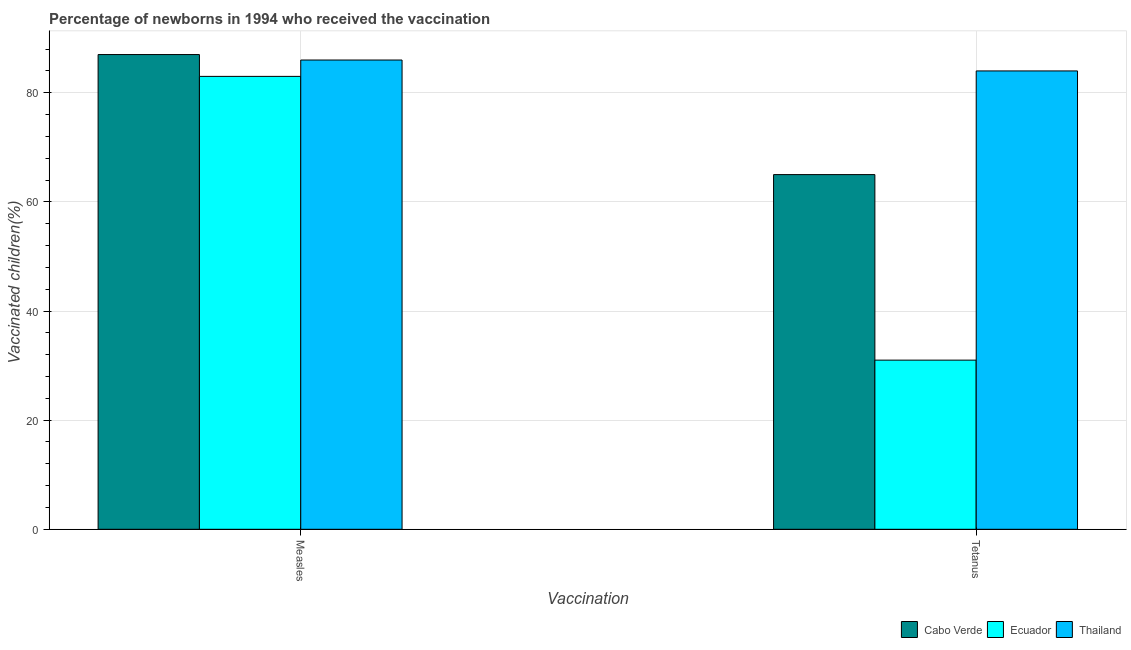How many groups of bars are there?
Your answer should be compact. 2. How many bars are there on the 2nd tick from the left?
Give a very brief answer. 3. What is the label of the 1st group of bars from the left?
Your response must be concise. Measles. What is the percentage of newborns who received vaccination for measles in Cabo Verde?
Provide a short and direct response. 87. Across all countries, what is the maximum percentage of newborns who received vaccination for measles?
Provide a short and direct response. 87. Across all countries, what is the minimum percentage of newborns who received vaccination for tetanus?
Keep it short and to the point. 31. In which country was the percentage of newborns who received vaccination for tetanus maximum?
Ensure brevity in your answer.  Thailand. In which country was the percentage of newborns who received vaccination for tetanus minimum?
Give a very brief answer. Ecuador. What is the total percentage of newborns who received vaccination for measles in the graph?
Offer a terse response. 256. What is the difference between the percentage of newborns who received vaccination for tetanus in Thailand and that in Ecuador?
Make the answer very short. 53. What is the difference between the percentage of newborns who received vaccination for measles in Cabo Verde and the percentage of newborns who received vaccination for tetanus in Thailand?
Your response must be concise. 3. What is the average percentage of newborns who received vaccination for tetanus per country?
Provide a short and direct response. 60. What is the difference between the percentage of newborns who received vaccination for tetanus and percentage of newborns who received vaccination for measles in Ecuador?
Your answer should be very brief. -52. What is the ratio of the percentage of newborns who received vaccination for measles in Cabo Verde to that in Ecuador?
Provide a succinct answer. 1.05. Is the percentage of newborns who received vaccination for measles in Ecuador less than that in Thailand?
Provide a short and direct response. Yes. In how many countries, is the percentage of newborns who received vaccination for tetanus greater than the average percentage of newborns who received vaccination for tetanus taken over all countries?
Your answer should be compact. 2. What does the 3rd bar from the left in Tetanus represents?
Offer a very short reply. Thailand. What does the 2nd bar from the right in Measles represents?
Make the answer very short. Ecuador. How many bars are there?
Provide a succinct answer. 6. Are all the bars in the graph horizontal?
Your answer should be very brief. No. How many countries are there in the graph?
Provide a succinct answer. 3. What is the difference between two consecutive major ticks on the Y-axis?
Offer a terse response. 20. Are the values on the major ticks of Y-axis written in scientific E-notation?
Provide a succinct answer. No. Does the graph contain any zero values?
Ensure brevity in your answer.  No. Does the graph contain grids?
Provide a short and direct response. Yes. Where does the legend appear in the graph?
Provide a short and direct response. Bottom right. How are the legend labels stacked?
Your answer should be very brief. Horizontal. What is the title of the graph?
Your answer should be compact. Percentage of newborns in 1994 who received the vaccination. What is the label or title of the X-axis?
Ensure brevity in your answer.  Vaccination. What is the label or title of the Y-axis?
Provide a succinct answer. Vaccinated children(%)
. What is the Vaccinated children(%)
 of Cabo Verde in Measles?
Ensure brevity in your answer.  87. What is the Vaccinated children(%)
 in Cabo Verde in Tetanus?
Your answer should be very brief. 65. What is the Vaccinated children(%)
 of Ecuador in Tetanus?
Provide a short and direct response. 31. Across all Vaccination, what is the maximum Vaccinated children(%)
 in Ecuador?
Your answer should be very brief. 83. Across all Vaccination, what is the maximum Vaccinated children(%)
 in Thailand?
Provide a succinct answer. 86. What is the total Vaccinated children(%)
 in Cabo Verde in the graph?
Make the answer very short. 152. What is the total Vaccinated children(%)
 in Ecuador in the graph?
Make the answer very short. 114. What is the total Vaccinated children(%)
 in Thailand in the graph?
Your response must be concise. 170. What is the difference between the Vaccinated children(%)
 in Ecuador in Measles and that in Tetanus?
Provide a succinct answer. 52. What is the difference between the Vaccinated children(%)
 in Thailand in Measles and that in Tetanus?
Give a very brief answer. 2. What is the difference between the Vaccinated children(%)
 in Cabo Verde in Measles and the Vaccinated children(%)
 in Ecuador in Tetanus?
Provide a succinct answer. 56. What is the difference between the Vaccinated children(%)
 of Cabo Verde in Measles and the Vaccinated children(%)
 of Thailand in Tetanus?
Offer a terse response. 3. What is the average Vaccinated children(%)
 in Cabo Verde per Vaccination?
Your answer should be compact. 76. What is the average Vaccinated children(%)
 in Ecuador per Vaccination?
Offer a terse response. 57. What is the difference between the Vaccinated children(%)
 of Cabo Verde and Vaccinated children(%)
 of Ecuador in Tetanus?
Provide a short and direct response. 34. What is the difference between the Vaccinated children(%)
 of Ecuador and Vaccinated children(%)
 of Thailand in Tetanus?
Your response must be concise. -53. What is the ratio of the Vaccinated children(%)
 of Cabo Verde in Measles to that in Tetanus?
Your response must be concise. 1.34. What is the ratio of the Vaccinated children(%)
 of Ecuador in Measles to that in Tetanus?
Offer a very short reply. 2.68. What is the ratio of the Vaccinated children(%)
 of Thailand in Measles to that in Tetanus?
Provide a succinct answer. 1.02. What is the difference between the highest and the second highest Vaccinated children(%)
 of Thailand?
Your answer should be very brief. 2. What is the difference between the highest and the lowest Vaccinated children(%)
 in Ecuador?
Your response must be concise. 52. 